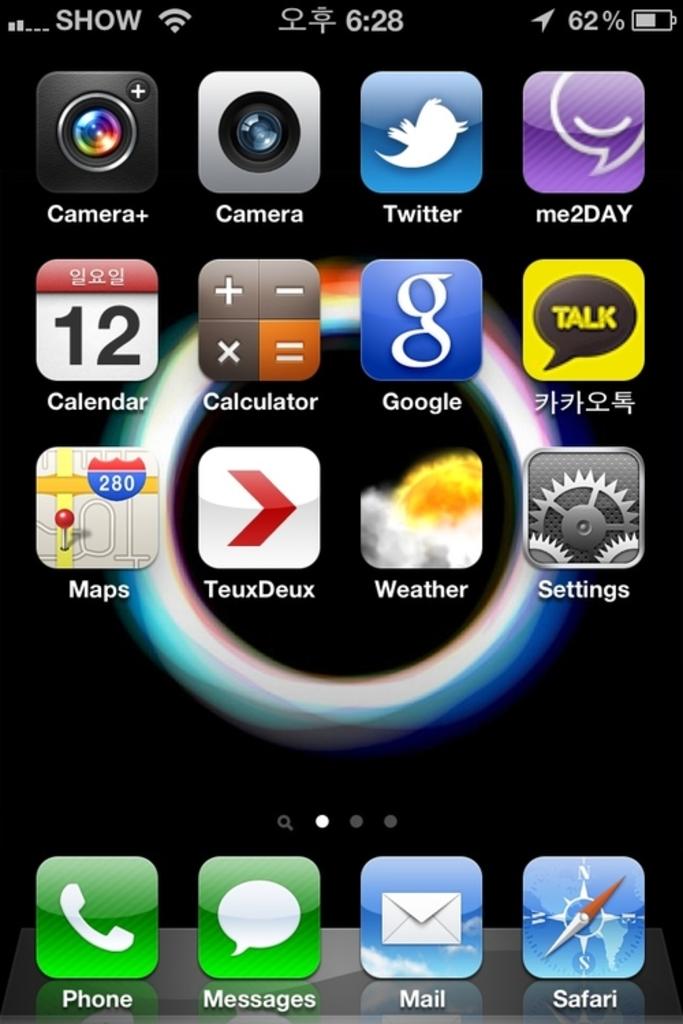What label does the purple icon in the upper right have?
Provide a succinct answer. Me2day. What do the two green aps say?
Keep it short and to the point. Phone and messages. 